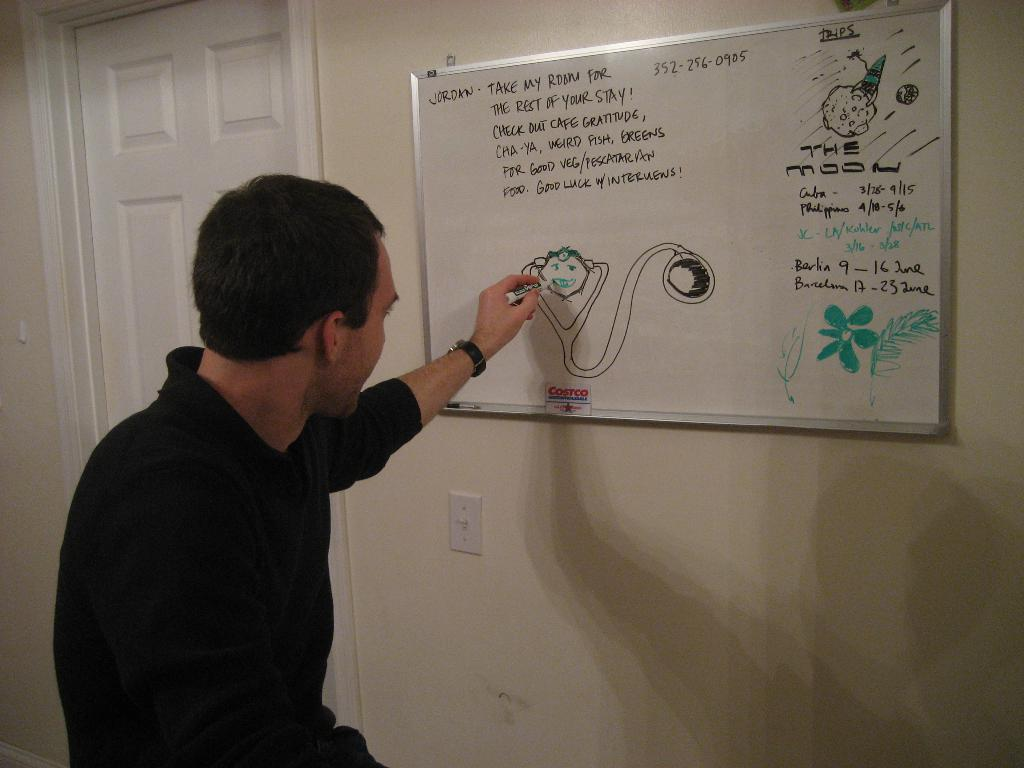<image>
Provide a brief description of the given image. A man is shown writing a message to Jordan and adding a cute drawing at the bottom. 